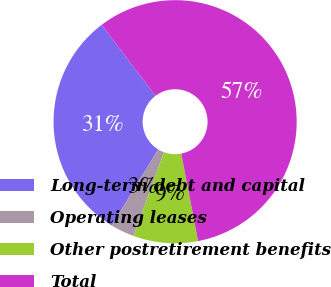Convert chart to OTSL. <chart><loc_0><loc_0><loc_500><loc_500><pie_chart><fcel>Long-term debt and capital<fcel>Operating leases<fcel>Other postretirement benefits<fcel>Total<nl><fcel>30.97%<fcel>3.17%<fcel>8.58%<fcel>57.28%<nl></chart> 